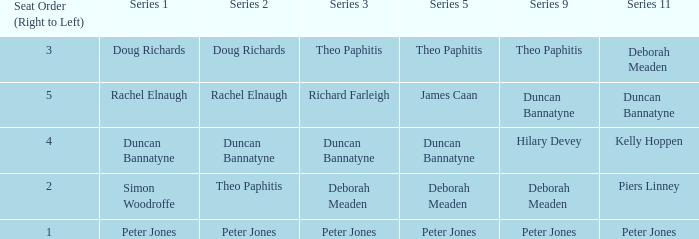Which Series 1 has a Series 11 of peter jones? Peter Jones. 